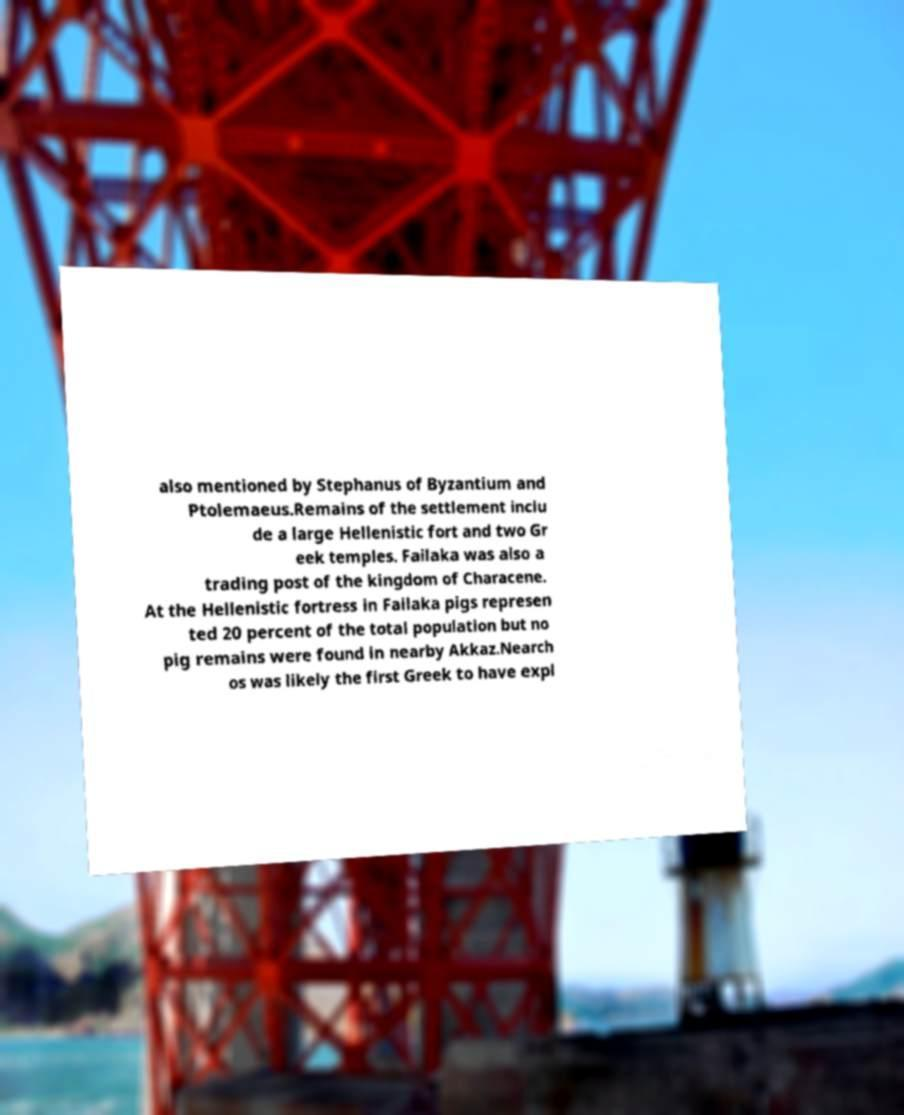Can you read and provide the text displayed in the image?This photo seems to have some interesting text. Can you extract and type it out for me? also mentioned by Stephanus of Byzantium and Ptolemaeus.Remains of the settlement inclu de a large Hellenistic fort and two Gr eek temples. Failaka was also a trading post of the kingdom of Characene. At the Hellenistic fortress in Failaka pigs represen ted 20 percent of the total population but no pig remains were found in nearby Akkaz.Nearch os was likely the first Greek to have expl 